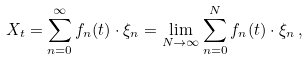Convert formula to latex. <formula><loc_0><loc_0><loc_500><loc_500>X _ { t } = \sum _ { n = 0 } ^ { \infty } f _ { n } ( t ) \cdot \xi _ { n } = \lim _ { N \to \infty } \sum _ { n = 0 } ^ { N } f _ { n } ( t ) \cdot \xi _ { n } \, ,</formula> 